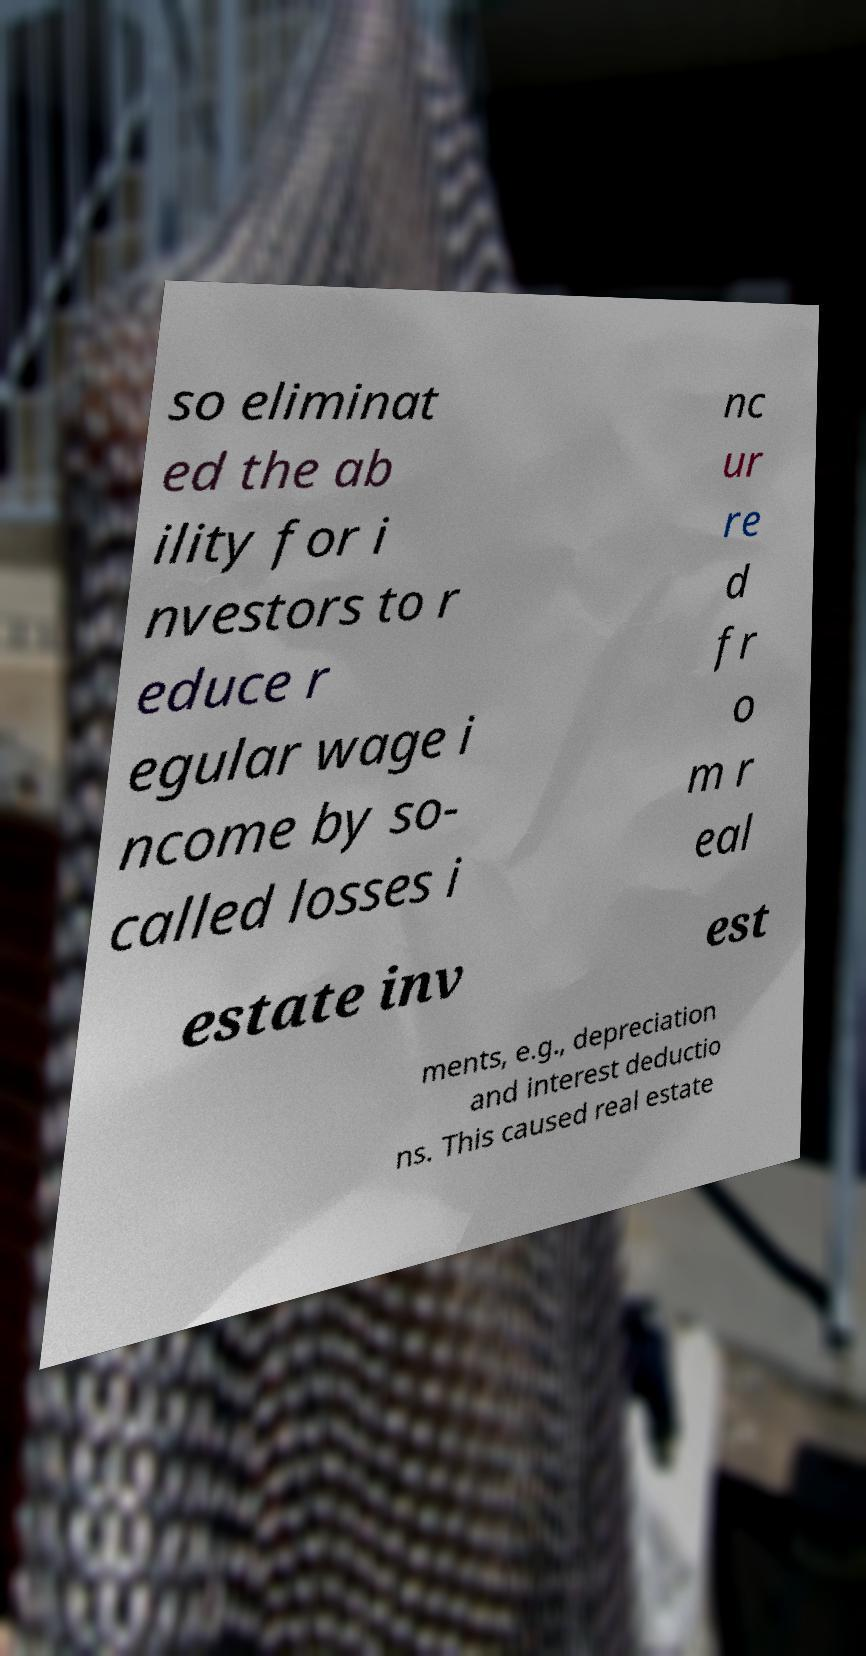Can you read and provide the text displayed in the image?This photo seems to have some interesting text. Can you extract and type it out for me? so eliminat ed the ab ility for i nvestors to r educe r egular wage i ncome by so- called losses i nc ur re d fr o m r eal estate inv est ments, e.g., depreciation and interest deductio ns. This caused real estate 